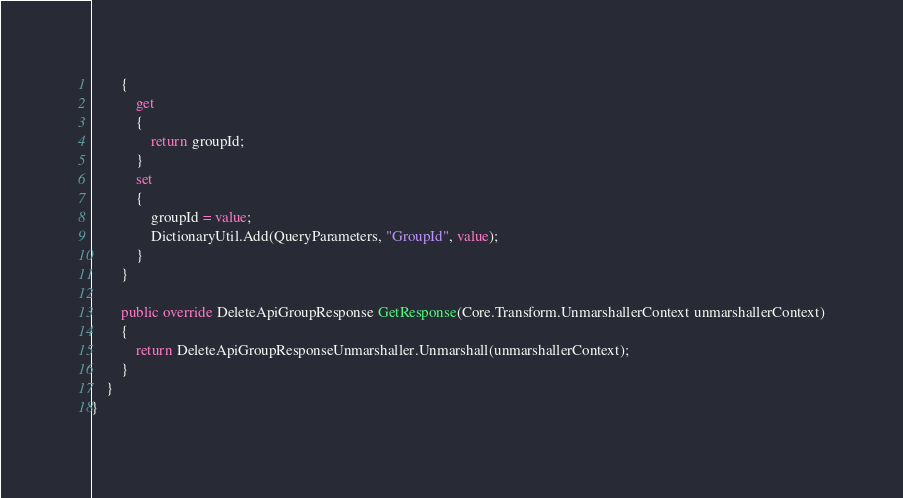Convert code to text. <code><loc_0><loc_0><loc_500><loc_500><_C#_>		{
			get
			{
				return groupId;
			}
			set	
			{
				groupId = value;
				DictionaryUtil.Add(QueryParameters, "GroupId", value);
			}
		}

        public override DeleteApiGroupResponse GetResponse(Core.Transform.UnmarshallerContext unmarshallerContext)
        {
            return DeleteApiGroupResponseUnmarshaller.Unmarshall(unmarshallerContext);
        }
    }
}</code> 